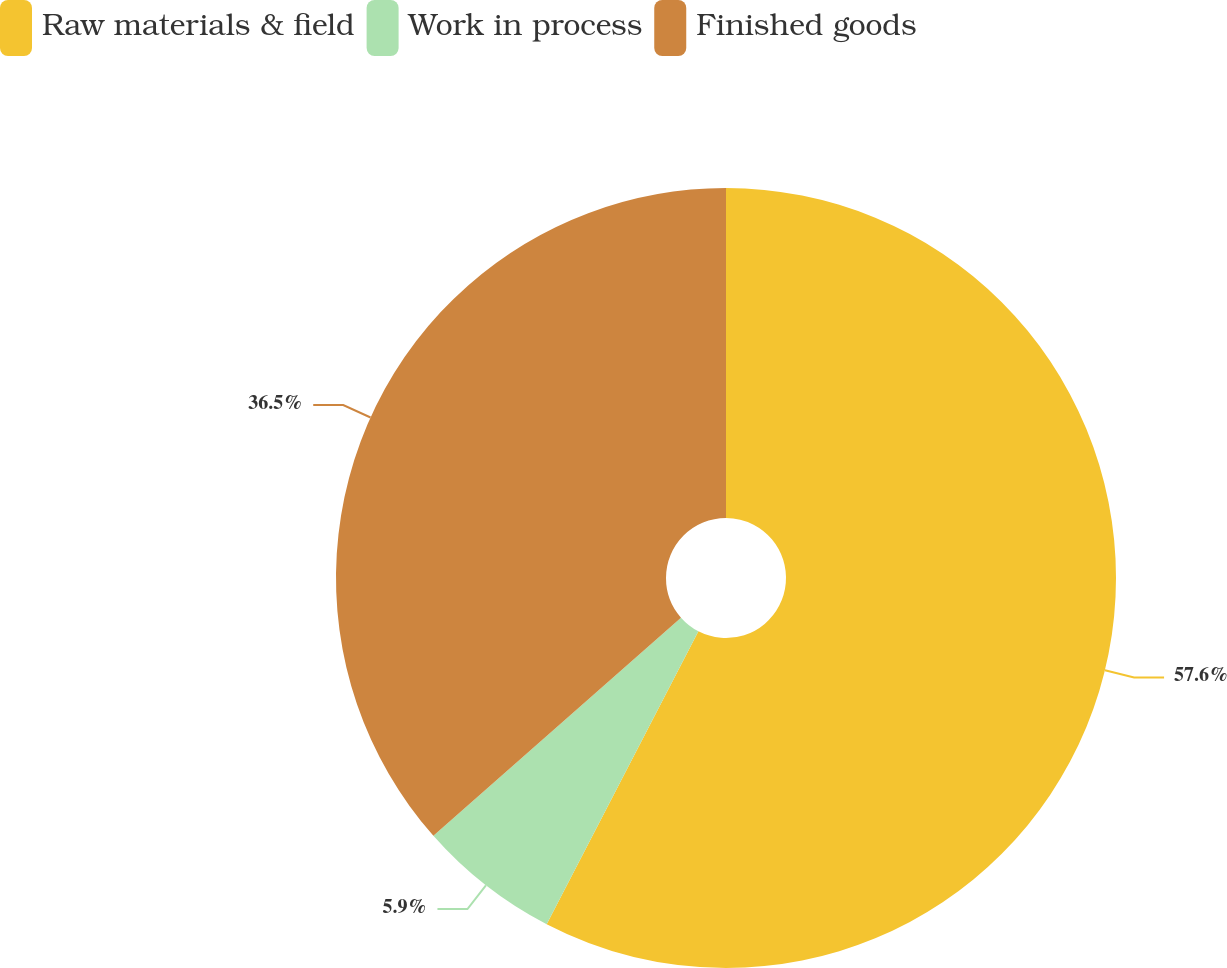<chart> <loc_0><loc_0><loc_500><loc_500><pie_chart><fcel>Raw materials & field<fcel>Work in process<fcel>Finished goods<nl><fcel>57.61%<fcel>5.9%<fcel>36.5%<nl></chart> 